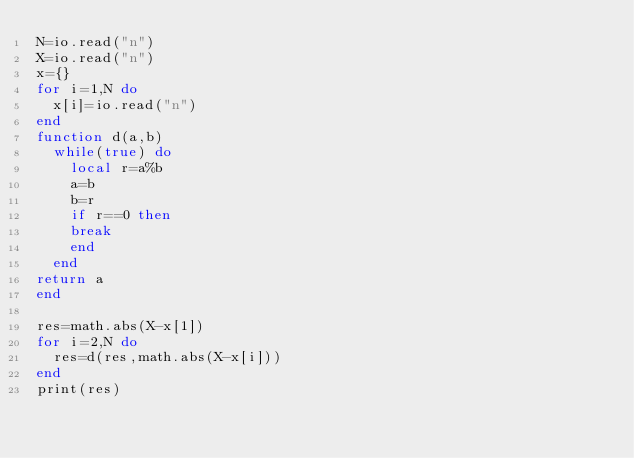Convert code to text. <code><loc_0><loc_0><loc_500><loc_500><_Lua_>N=io.read("n")
X=io.read("n")
x={}
for i=1,N do
  x[i]=io.read("n")
end
function d(a,b)
  while(true) do
  	local r=a%b
  	a=b
  	b=r
 	if r==0 then
    break
    end
  end
return a
end
    	
res=math.abs(X-x[1])
for i=2,N do
  res=d(res,math.abs(X-x[i]))
end
print(res)</code> 